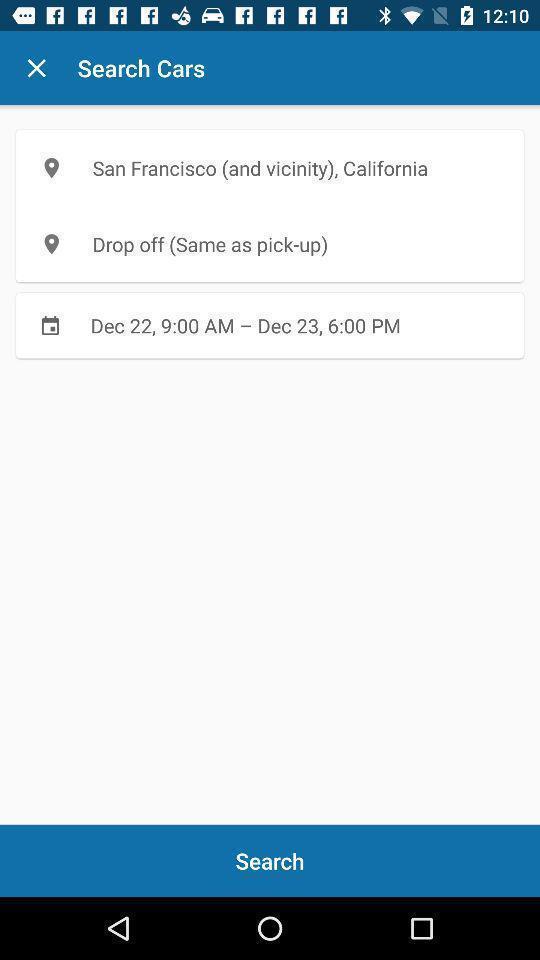Describe this image in words. Search options a showing an a location setting. 